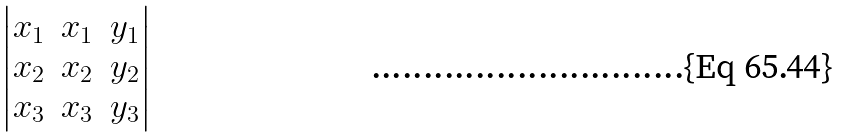Convert formula to latex. <formula><loc_0><loc_0><loc_500><loc_500>\begin{vmatrix} x _ { 1 } & x _ { 1 } & y _ { 1 } \\ x _ { 2 } & x _ { 2 } & y _ { 2 } \\ x _ { 3 } & x _ { 3 } & y _ { 3 } \end{vmatrix}</formula> 